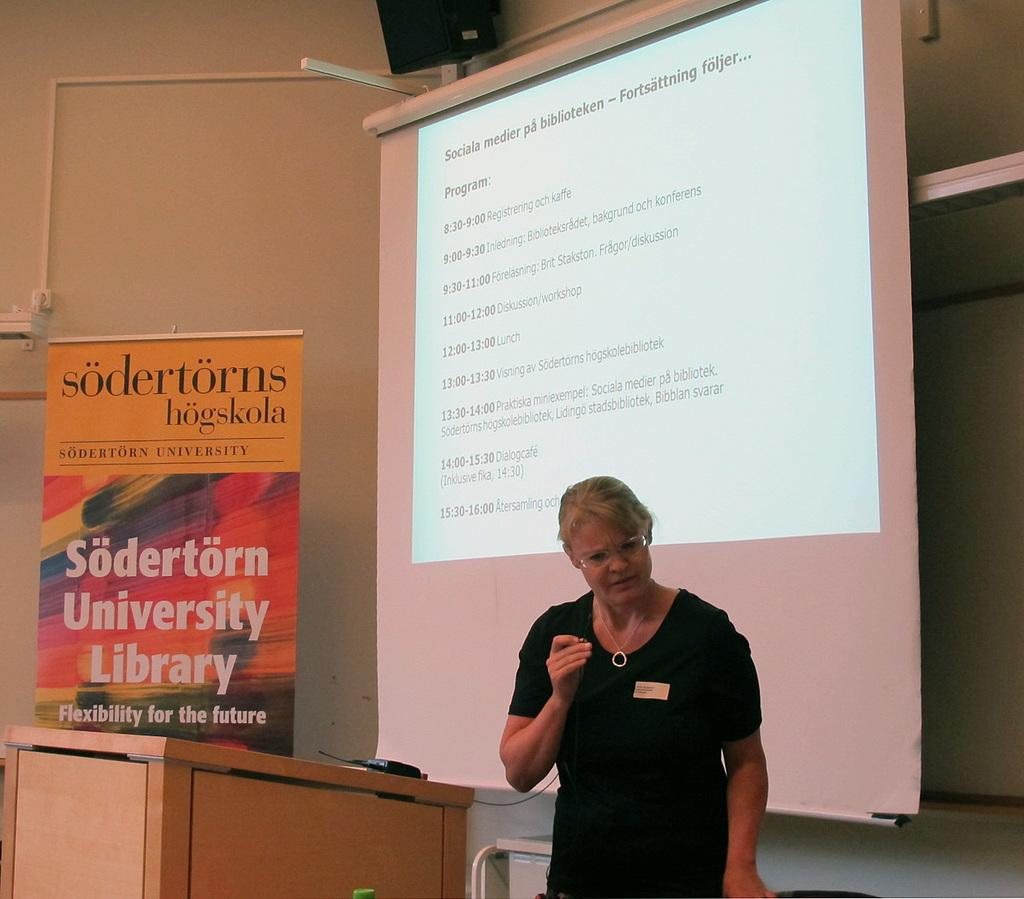<image>
Render a clear and concise summary of the photo. A lady speaks next to a sodertorns sign 